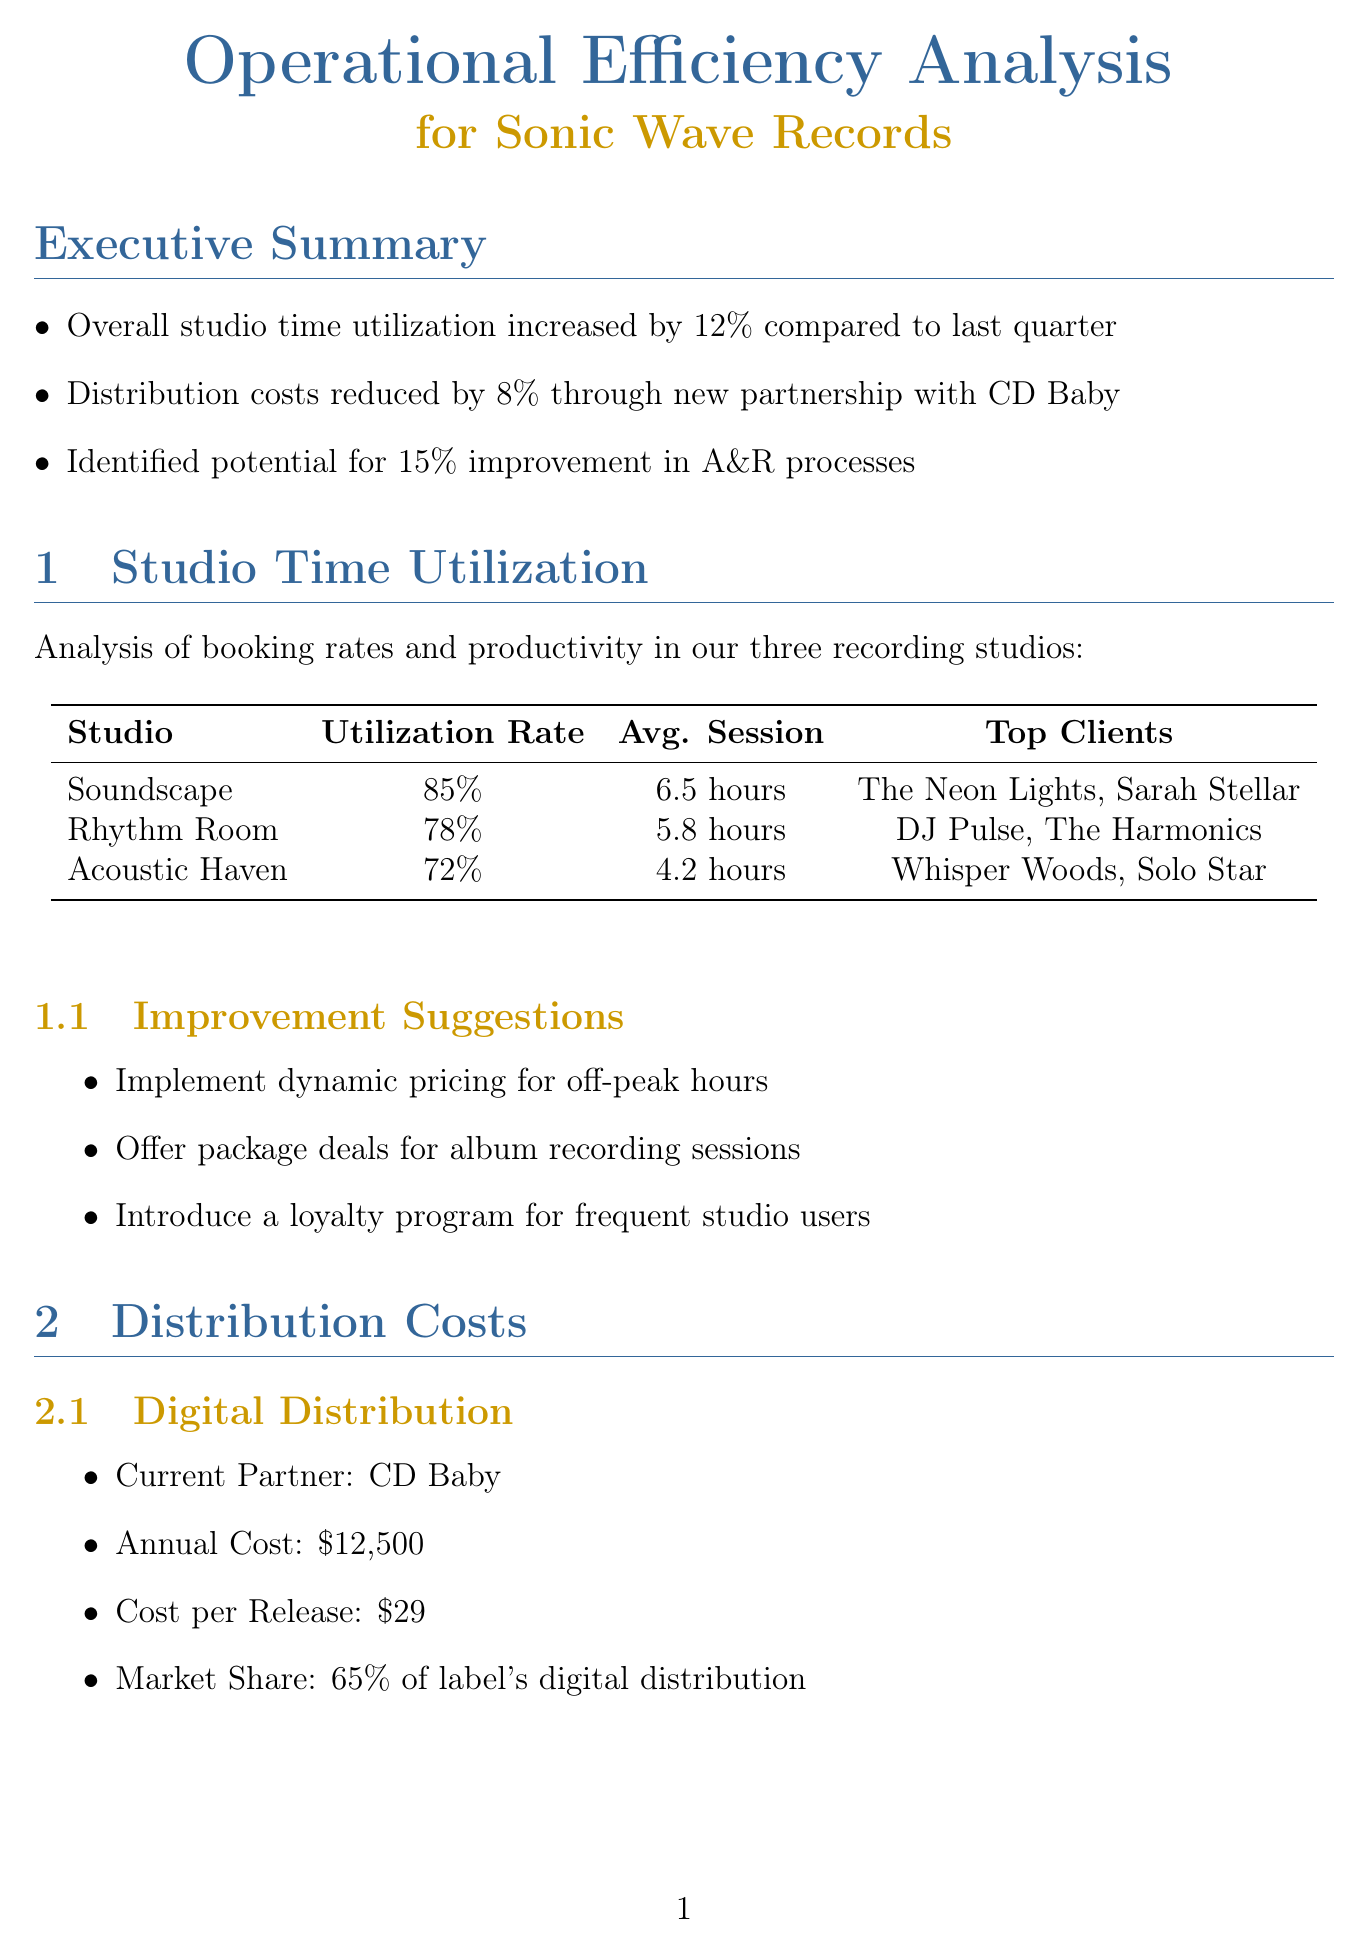What is the overall studio time utilization increase? The overall studio time utilization increased by 12% compared to last quarter.
Answer: 12% What is the annual cost of digital distribution with CD Baby? The annual cost of digital distribution with CD Baby is stated in the report.
Answer: $12,500 Which studio has the highest utilization rate? The studio with the highest utilization rate is noted in the studio data analysis.
Answer: Soundscape Studio What are the proposed solutions for A&R challenges? Proposed solutions for A&R are listed under the process improvement areas.
Answer: Standardized scoring system for demos, quarterly showcases, AI-powered trend analysis What is the average cost per CD? The average cost per CD is detailed in the physical distribution section.
Answer: $2.20 What is one of the priority actions to improve operations? Priority actions are listed in the conclusion and next steps section of the report.
Answer: Implement dynamic studio pricing within the next 30 days What is the target for studio utilization in the long-term goals? Long-term goals provide specific targets for studio utilization, achieved through improved processes.
Answer: 90% What is the market share of the label's digital distribution? Market share information is included in the digital distribution subsection.
Answer: 65% What is one challenge in royalty accounting? Challenges in royalty accounting are outlined in the process improvement areas section.
Answer: Delays in processing streaming royalties 